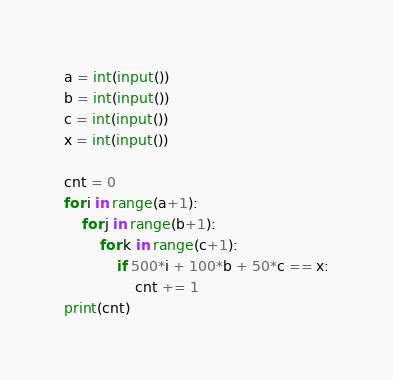<code> <loc_0><loc_0><loc_500><loc_500><_Python_>a = int(input())
b = int(input())
c = int(input())
x = int(input())

cnt = 0
for i in range(a+1):
    for j in range(b+1):
        for k in range(c+1):
            if 500*i + 100*b + 50*c == x:
                cnt += 1
print(cnt)</code> 